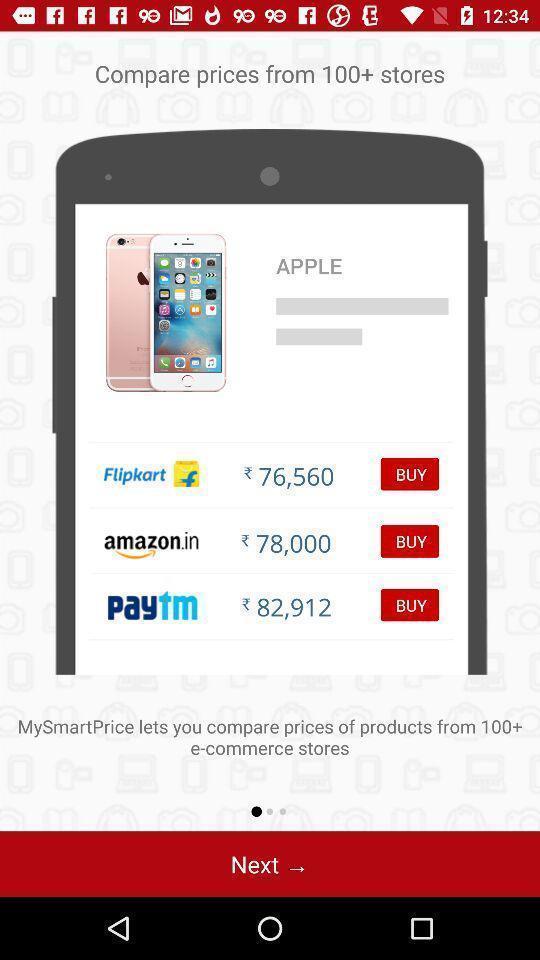Provide a detailed account of this screenshot. Welcome page of a shopping app. 